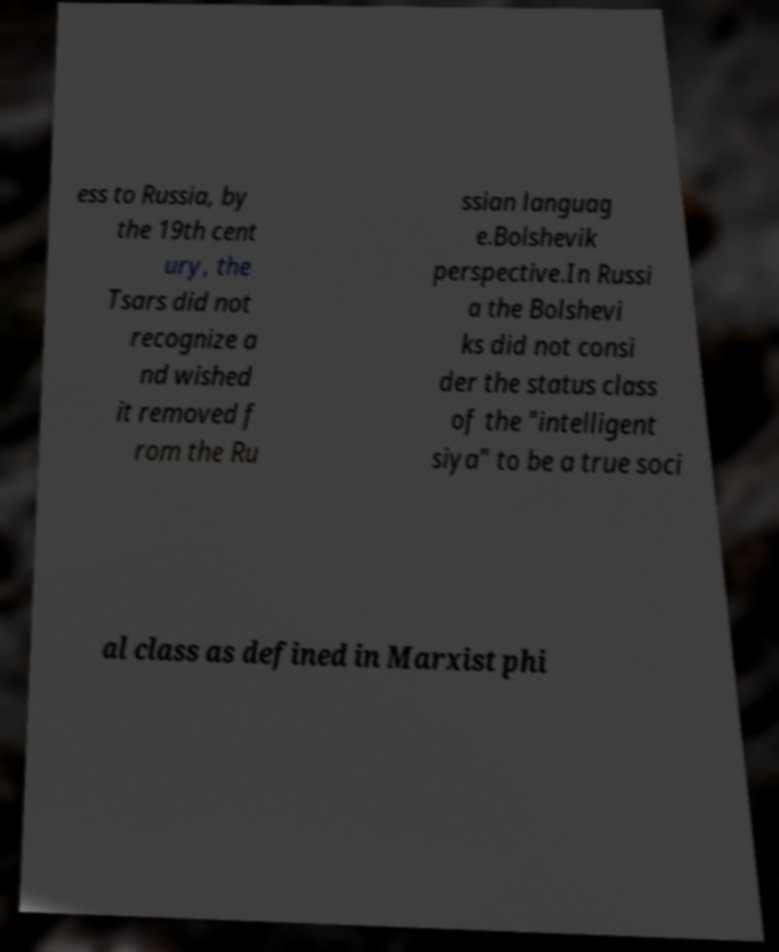Can you read and provide the text displayed in the image?This photo seems to have some interesting text. Can you extract and type it out for me? ess to Russia, by the 19th cent ury, the Tsars did not recognize a nd wished it removed f rom the Ru ssian languag e.Bolshevik perspective.In Russi a the Bolshevi ks did not consi der the status class of the "intelligent siya" to be a true soci al class as defined in Marxist phi 